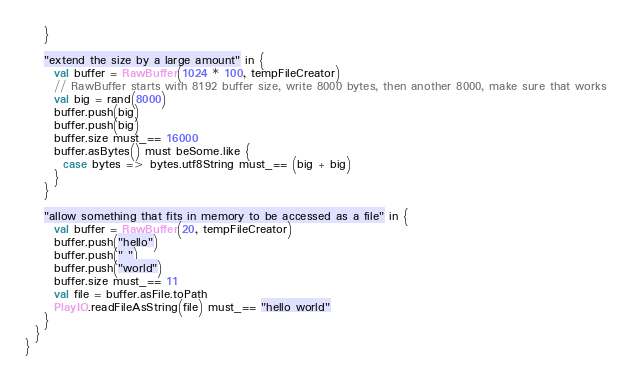Convert code to text. <code><loc_0><loc_0><loc_500><loc_500><_Scala_>    }

    "extend the size by a large amount" in {
      val buffer = RawBuffer(1024 * 100, tempFileCreator)
      // RawBuffer starts with 8192 buffer size, write 8000 bytes, then another 8000, make sure that works
      val big = rand(8000)
      buffer.push(big)
      buffer.push(big)
      buffer.size must_== 16000
      buffer.asBytes() must beSome.like {
        case bytes => bytes.utf8String must_== (big + big)
      }
    }

    "allow something that fits in memory to be accessed as a file" in {
      val buffer = RawBuffer(20, tempFileCreator)
      buffer.push("hello")
      buffer.push(" ")
      buffer.push("world")
      buffer.size must_== 11
      val file = buffer.asFile.toPath
      PlayIO.readFileAsString(file) must_== "hello world"
    }
  }
}
</code> 